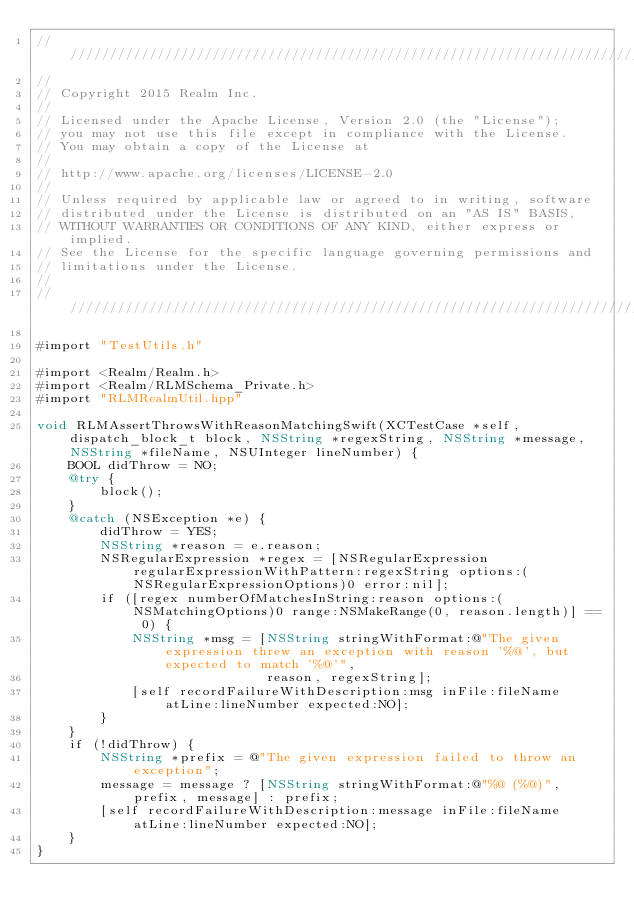Convert code to text. <code><loc_0><loc_0><loc_500><loc_500><_ObjectiveC_>////////////////////////////////////////////////////////////////////////////
//
// Copyright 2015 Realm Inc.
//
// Licensed under the Apache License, Version 2.0 (the "License");
// you may not use this file except in compliance with the License.
// You may obtain a copy of the License at
//
// http://www.apache.org/licenses/LICENSE-2.0
//
// Unless required by applicable law or agreed to in writing, software
// distributed under the License is distributed on an "AS IS" BASIS,
// WITHOUT WARRANTIES OR CONDITIONS OF ANY KIND, either express or implied.
// See the License for the specific language governing permissions and
// limitations under the License.
//
////////////////////////////////////////////////////////////////////////////

#import "TestUtils.h"

#import <Realm/Realm.h>
#import <Realm/RLMSchema_Private.h>
#import "RLMRealmUtil.hpp"

void RLMAssertThrowsWithReasonMatchingSwift(XCTestCase *self, dispatch_block_t block, NSString *regexString, NSString *message, NSString *fileName, NSUInteger lineNumber) {
    BOOL didThrow = NO;
    @try {
        block();
    }
    @catch (NSException *e) {
        didThrow = YES;
        NSString *reason = e.reason;
        NSRegularExpression *regex = [NSRegularExpression regularExpressionWithPattern:regexString options:(NSRegularExpressionOptions)0 error:nil];
        if ([regex numberOfMatchesInString:reason options:(NSMatchingOptions)0 range:NSMakeRange(0, reason.length)] == 0) {
            NSString *msg = [NSString stringWithFormat:@"The given expression threw an exception with reason '%@', but expected to match '%@'",
                             reason, regexString];
            [self recordFailureWithDescription:msg inFile:fileName atLine:lineNumber expected:NO];
        }
    }
    if (!didThrow) {
        NSString *prefix = @"The given expression failed to throw an exception";
        message = message ? [NSString stringWithFormat:@"%@ (%@)",  prefix, message] : prefix;
        [self recordFailureWithDescription:message inFile:fileName atLine:lineNumber expected:NO];
    }
}
</code> 